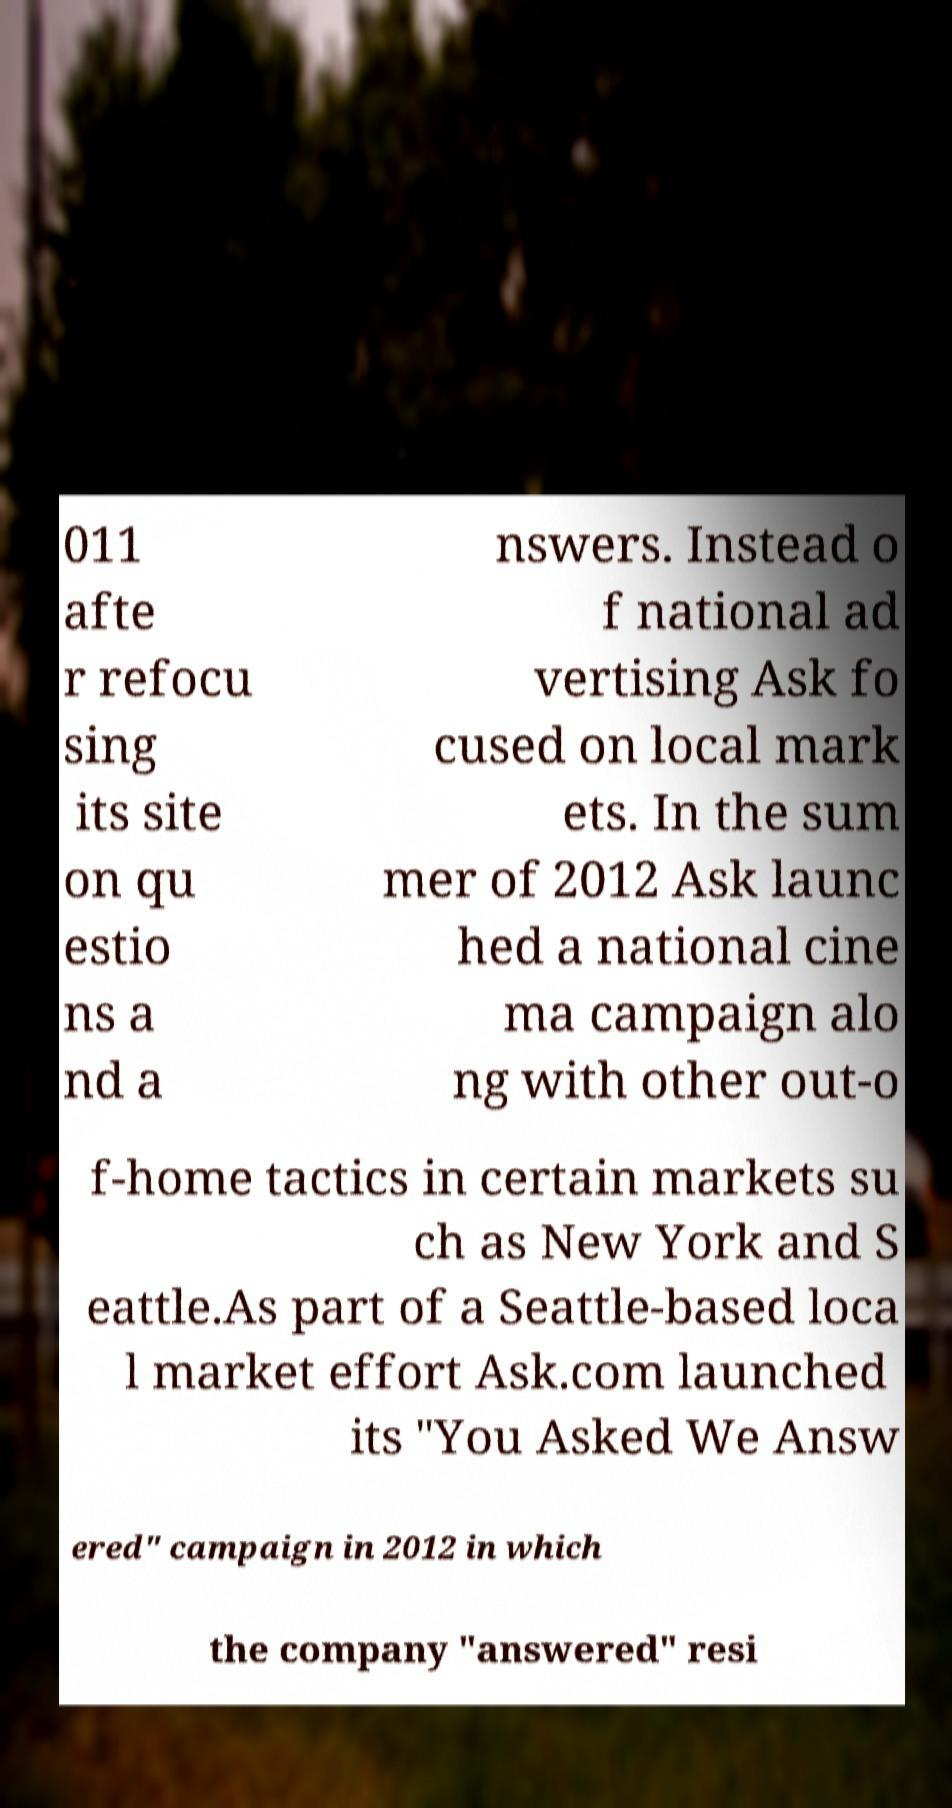Could you assist in decoding the text presented in this image and type it out clearly? 011 afte r refocu sing its site on qu estio ns a nd a nswers. Instead o f national ad vertising Ask fo cused on local mark ets. In the sum mer of 2012 Ask launc hed a national cine ma campaign alo ng with other out-o f-home tactics in certain markets su ch as New York and S eattle.As part of a Seattle-based loca l market effort Ask.com launched its "You Asked We Answ ered" campaign in 2012 in which the company "answered" resi 